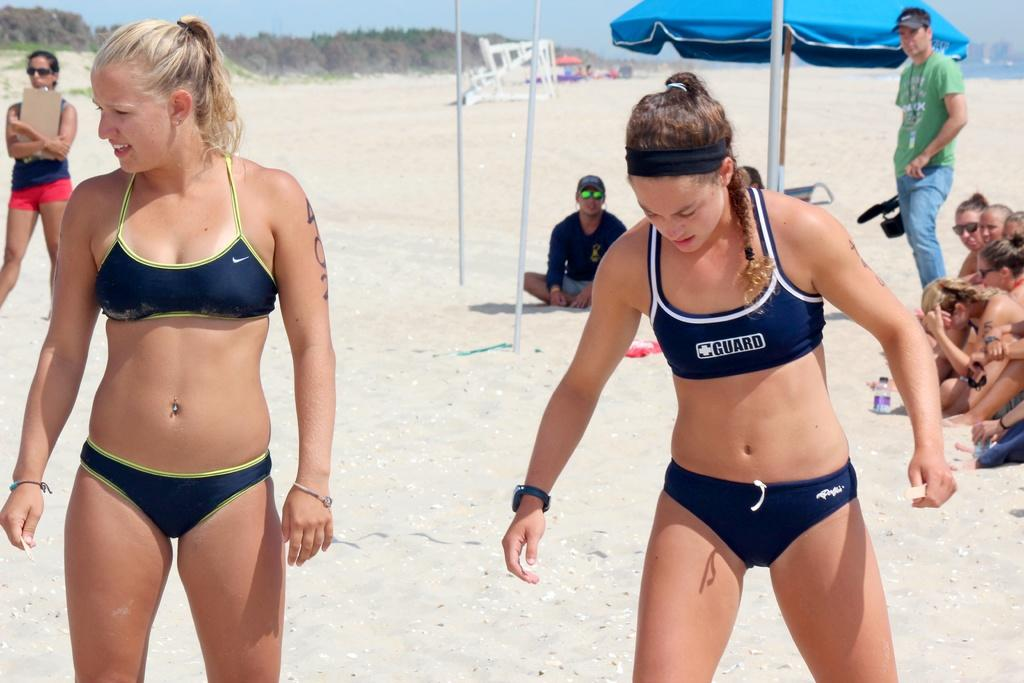<image>
Provide a brief description of the given image. women in volleyball clothes that say GUARD stand on a beach 